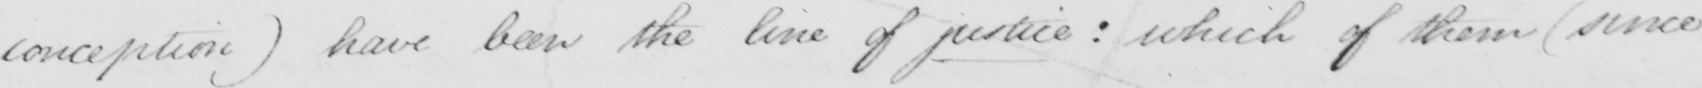Can you read and transcribe this handwriting? conception) have been the line of justice: which of them (since 